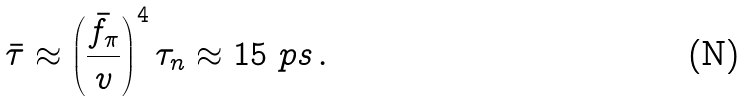<formula> <loc_0><loc_0><loc_500><loc_500>\bar { \tau } \approx \left ( \frac { \bar { f } _ { \pi } } { v } \right ) ^ { 4 } \tau _ { n } \approx 1 5 \ p s \, .</formula> 